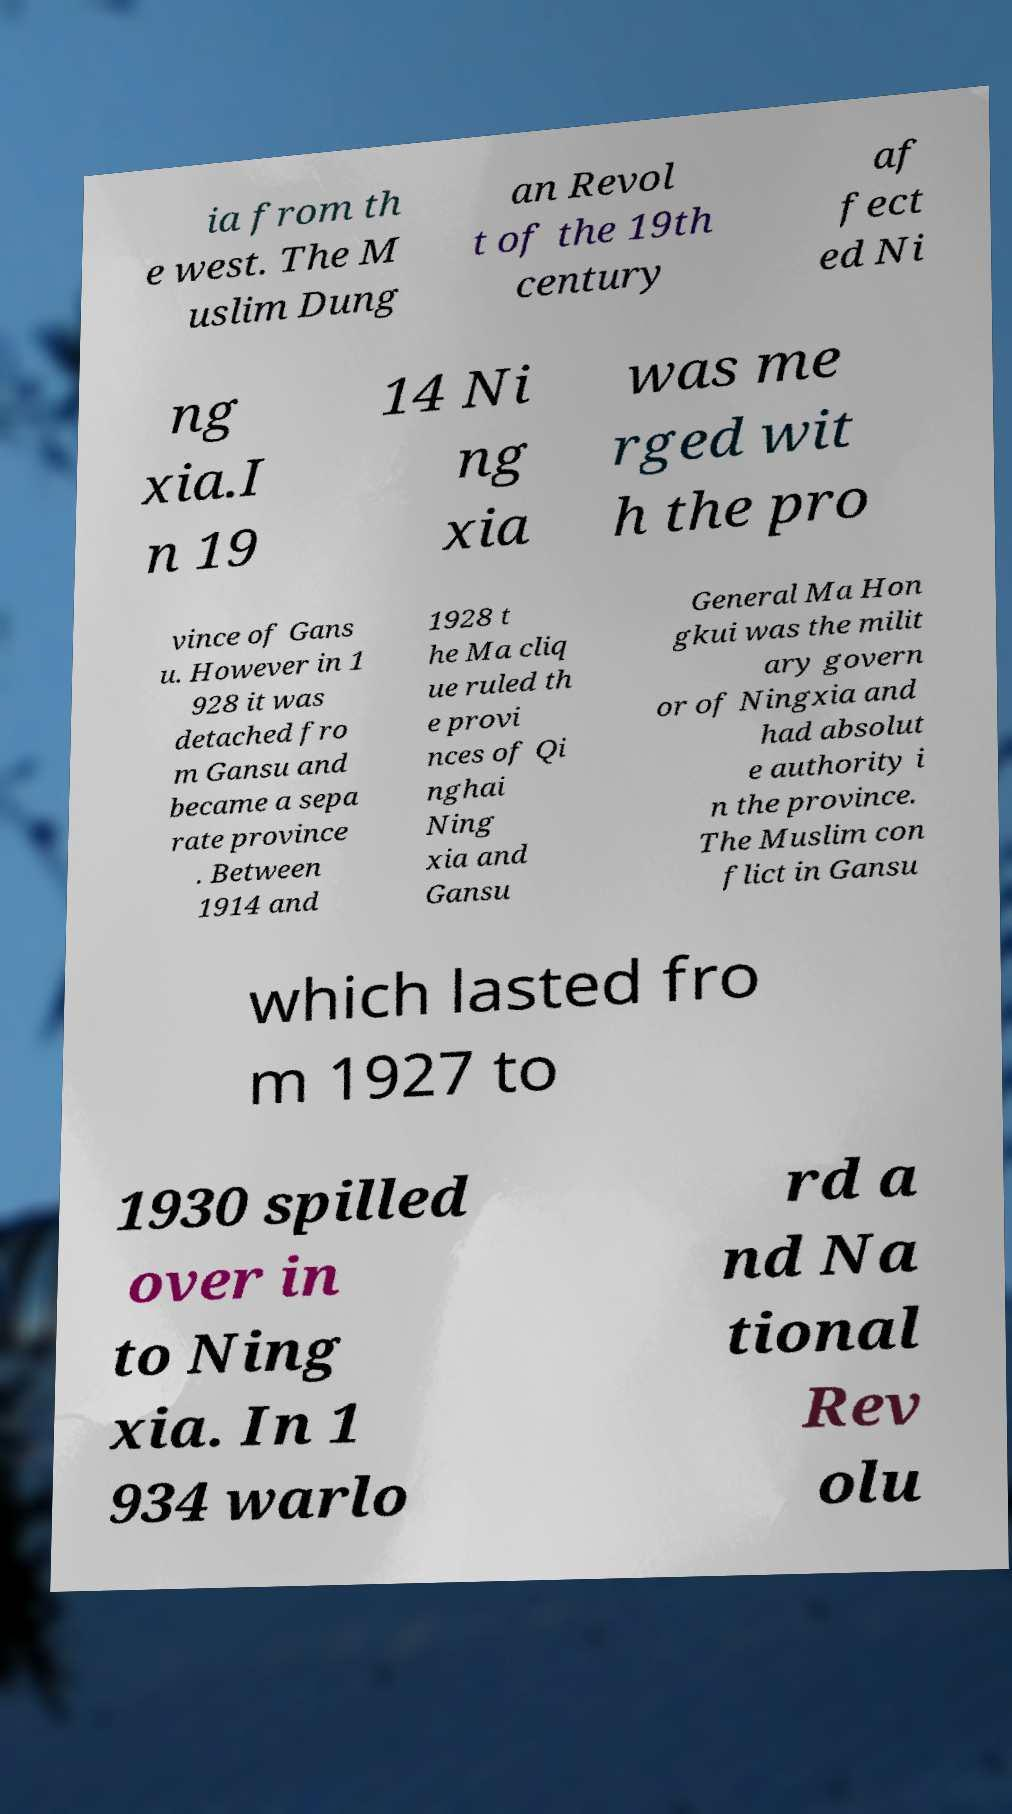I need the written content from this picture converted into text. Can you do that? ia from th e west. The M uslim Dung an Revol t of the 19th century af fect ed Ni ng xia.I n 19 14 Ni ng xia was me rged wit h the pro vince of Gans u. However in 1 928 it was detached fro m Gansu and became a sepa rate province . Between 1914 and 1928 t he Ma cliq ue ruled th e provi nces of Qi nghai Ning xia and Gansu General Ma Hon gkui was the milit ary govern or of Ningxia and had absolut e authority i n the province. The Muslim con flict in Gansu which lasted fro m 1927 to 1930 spilled over in to Ning xia. In 1 934 warlo rd a nd Na tional Rev olu 